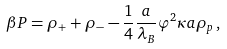Convert formula to latex. <formula><loc_0><loc_0><loc_500><loc_500>\beta P = \rho _ { + } + \rho _ { - } - \frac { 1 } { 4 } \frac { a } { \lambda _ { B } } \varphi ^ { 2 } \kappa a \rho _ { p } \, ,</formula> 